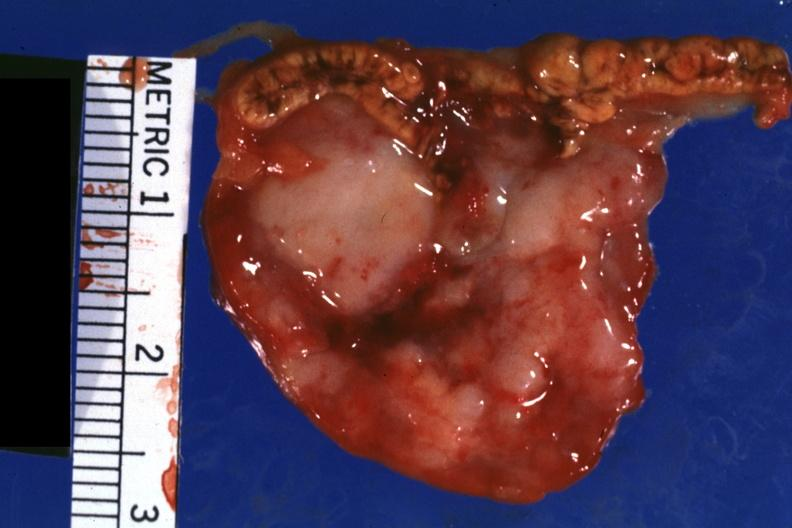does omphalocele show close-up tumor is shown well?
Answer the question using a single word or phrase. No 